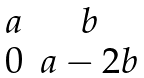<formula> <loc_0><loc_0><loc_500><loc_500>\begin{matrix} a & b \\ 0 & a - 2 b \end{matrix}</formula> 